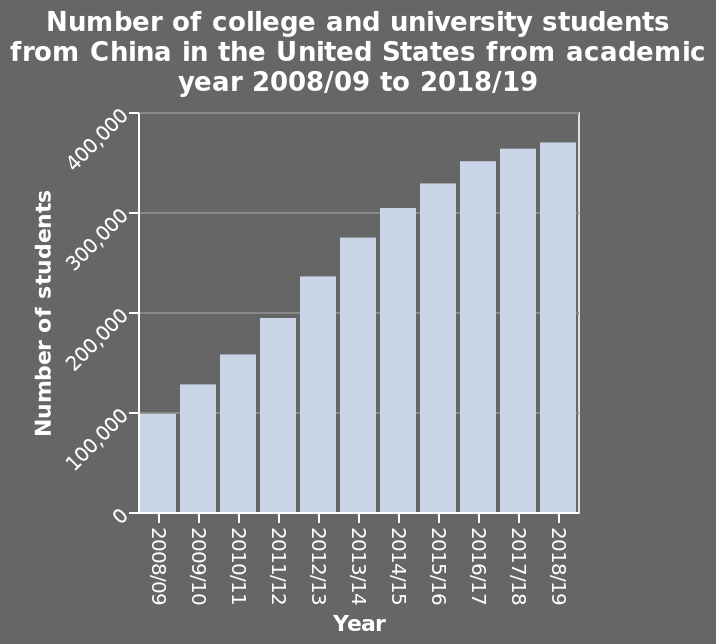<image>
What is the trend in the numbers over the years? The trend in the numbers is an increase year on year. How many students were there in the academic year 2008/09? The number of students in the academic year 2008/09 is not specified in the description. Is the number of students in the academic year 2008/09 specified in the figure? No.The number of students in the academic year 2008/09 is not specified in the figure. Is the trend in the numbers a decrease year on year? No.The trend in the numbers is an increase year on year. 